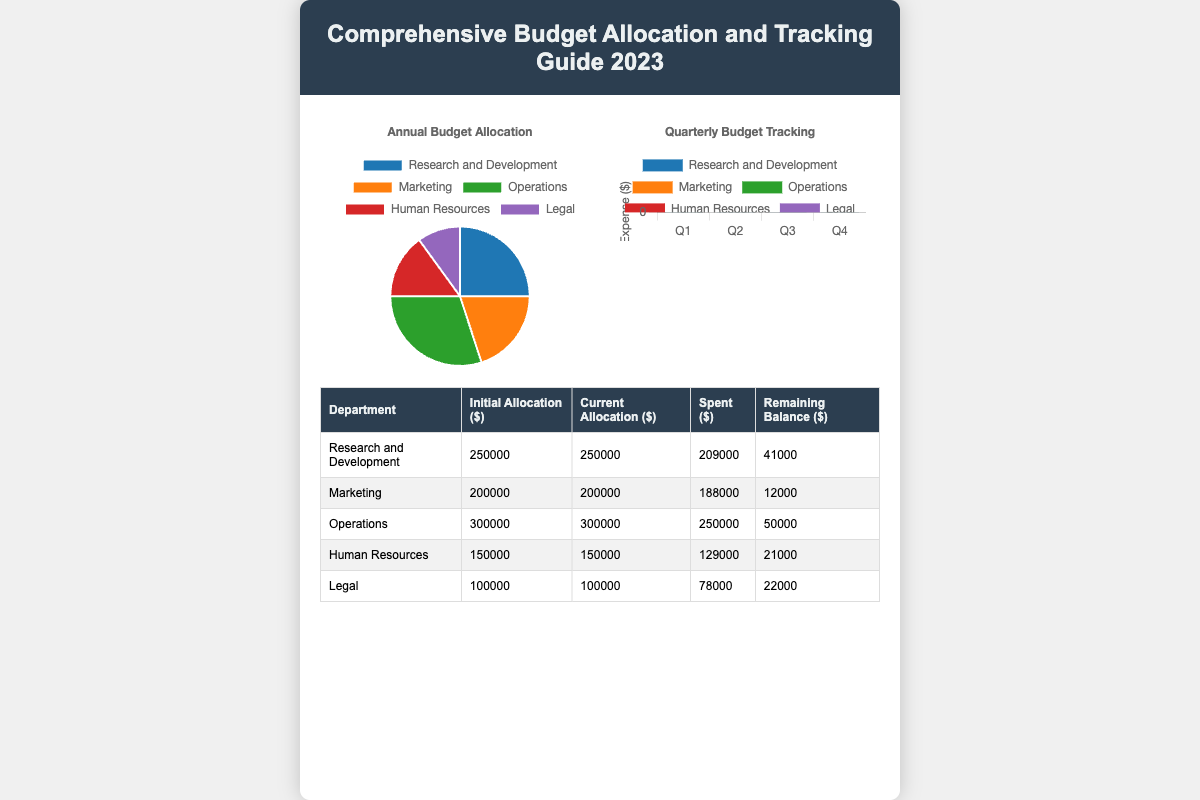What is the title of the document? The title is displayed prominently at the top of the document in the header section.
Answer: Comprehensive Budget Allocation and Tracking Guide 2023 What department has the highest initial allocation? By reviewing the table, we can determine which department received the most funds initially.
Answer: Operations What is the remaining balance for Human Resources? The remaining balance can be found in the last column of the table specifically related to Human Resources.
Answer: 21000 How much was spent by the Marketing department? The spent amount is listed under the "Spent ($)" column for the Marketing department.
Answer: 188000 What is the total budget allocated to Research and Development in 2023? The total budget allocation can be found in the second column corresponding to Research and Development.
Answer: 250000 How many departments are represented in this guide? Counting the number of unique departments listed in the table will provide the answer.
Answer: 5 What is the maximum spent amount among all departments? By comparing the spent amounts across all departments, we can identify the maximum.
Answer: 250000 Which chart displays the annual budget allocation? The title above the pie chart specifies the type of data it presents for the user.
Answer: Annual Budget Allocation What color represents the Legal department in the pie chart? The color coding in the pie chart allows us to determine the specific color allocated to the Legal department.
Answer: Purple 